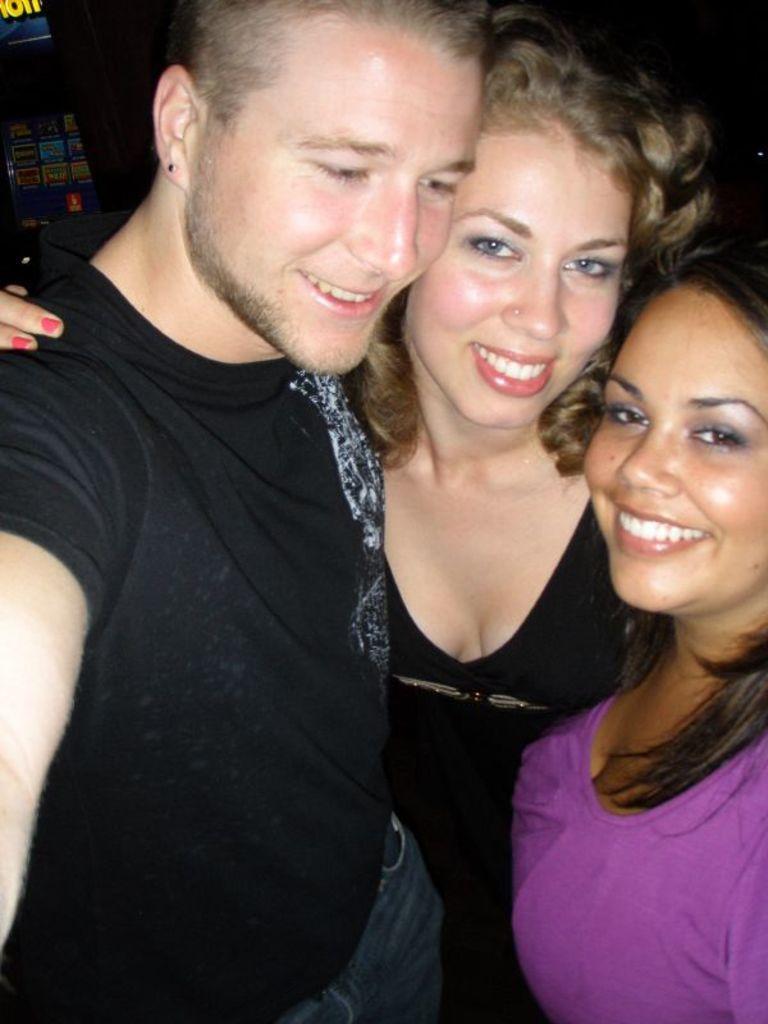In one or two sentences, can you explain what this image depicts? In this image I can see a person wearing black colored t shirt, a woman wearing black colored dress and another woman wearing pink colored dress are standing and smiling. I can see an electronic gadget and the dark background. 